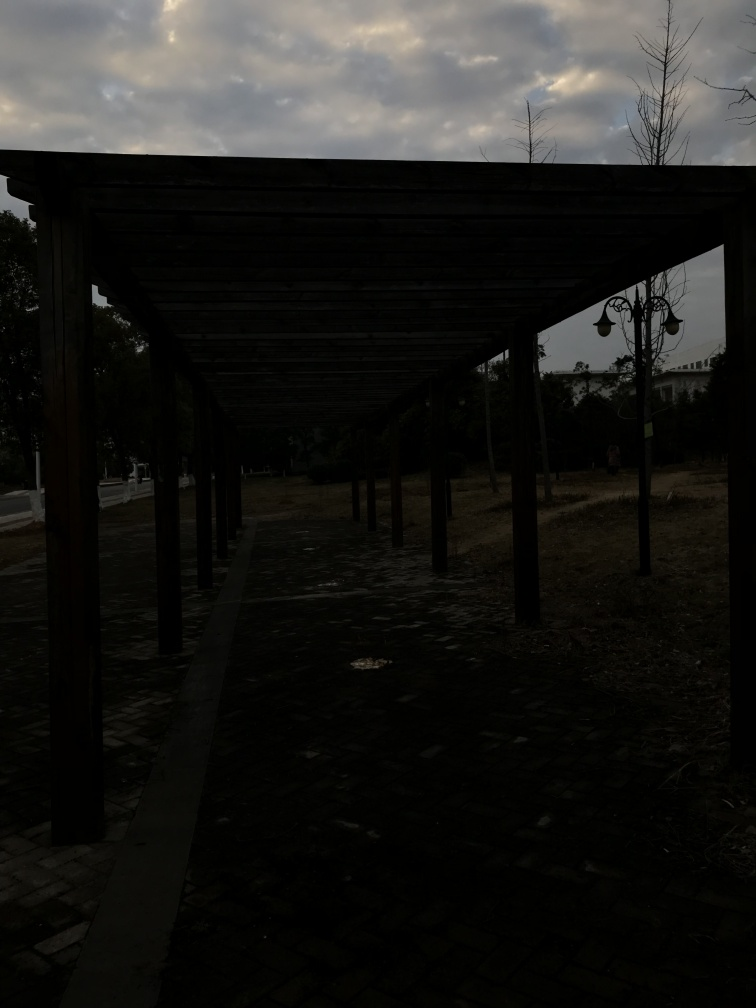Can you describe the structure visible in the image? The structure appears to be a pergola or some form of covered walkway with a wooden latticed roof supported by evenly spaced vertical beams. It creates a pathway and provides a partial cover, possibly intended for shade. 